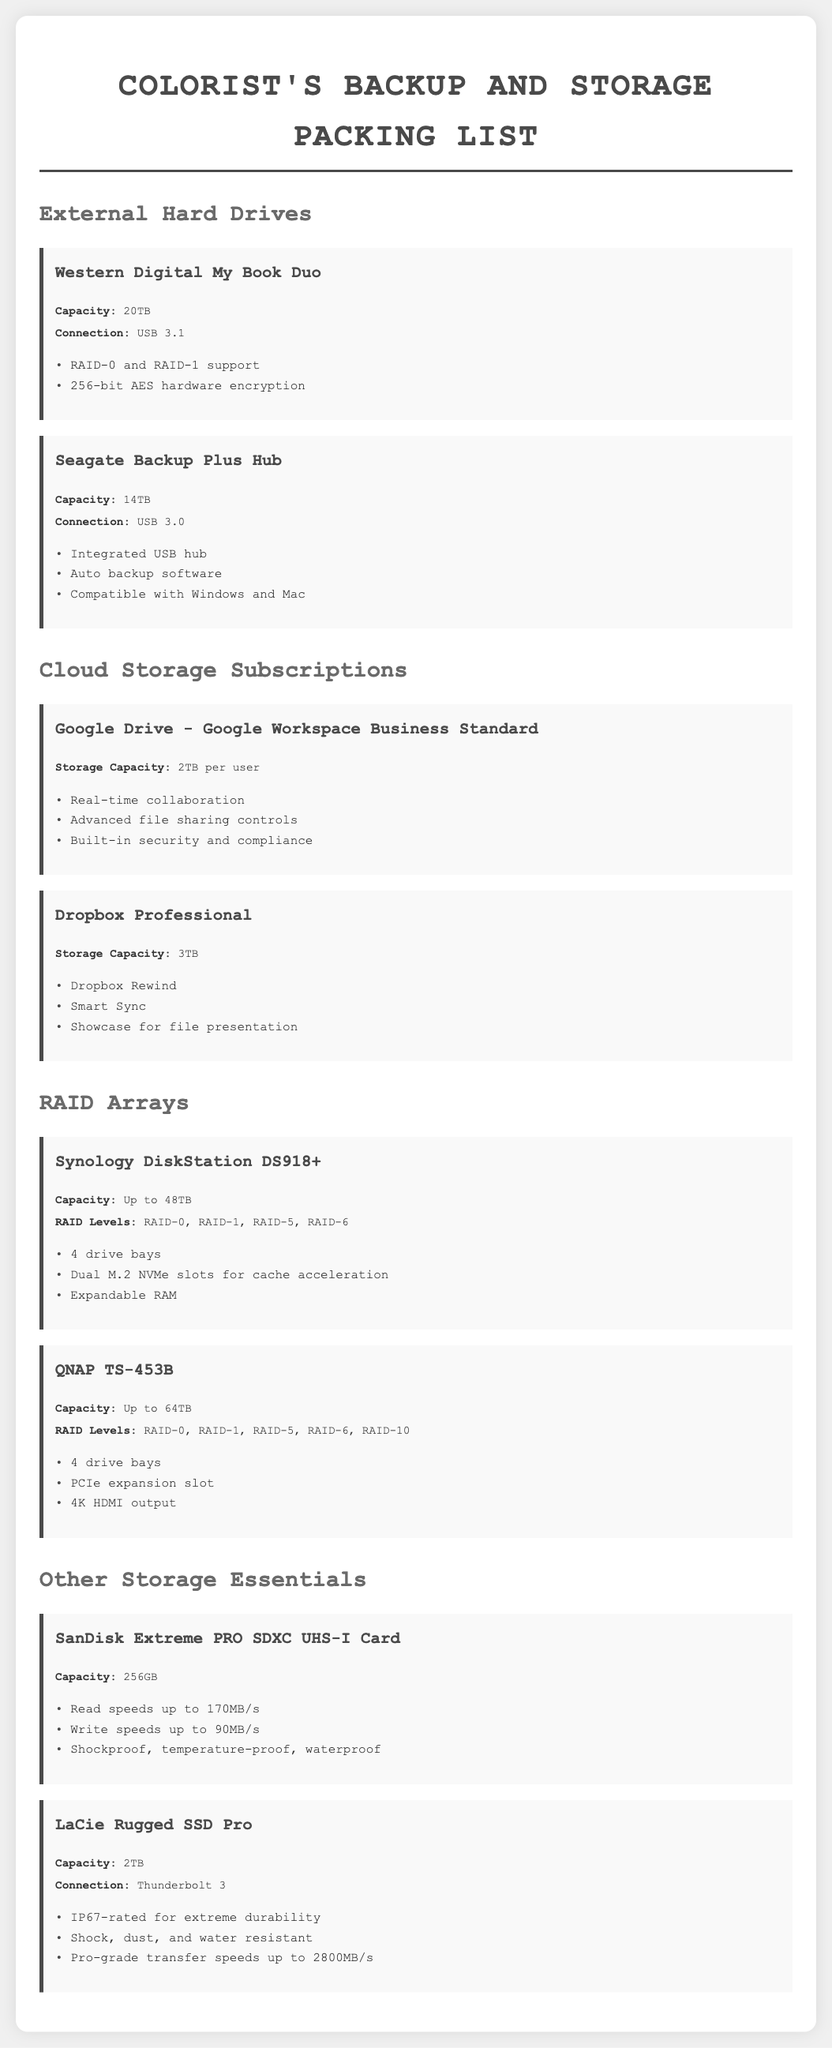What is the capacity of the Western Digital My Book Duo? The capacity is stated directly in the document as 20TB.
Answer: 20TB What type of connection does the Seagate Backup Plus Hub use? The document specifies that it uses a USB 3.0 connection.
Answer: USB 3.0 How much storage does the Dropbox Professional subscription offer? The document lists the storage capacity for Dropbox Professional as 3TB.
Answer: 3TB What RAID levels does the QNAP TS-453B support? The document highlights that it supports multiple RAID levels including RAID-0, RAID-1, RAID-5, RAID-6, and RAID-10.
Answer: RAID-0, RAID-1, RAID-5, RAID-6, RAID-10 What is unique about the SanDisk Extreme PRO SDXC UHS-I Card? The document mentions that it has read speeds up to 170MB/s.
Answer: Read speeds up to 170MB/s Which external hard drive has a RAID-0 and RAID-1 support feature? The document states that the Western Digital My Book Duo supports both RAID-0 and RAID-1.
Answer: Western Digital My Book Duo Which cloud storage solution allows real-time collaboration? The document indicates that Google Drive - Google Workspace Business Standard allows for real-time collaboration.
Answer: Google Drive - Google Workspace Business Standard What is the storage capacity of the Google Drive - Google Workspace Business Standard subscription? The document specifies that it offers 2TB per user.
Answer: 2TB per user How many drive bays does the Synology DiskStation DS918+ have? The document mentions that the Synology DiskStation DS918+ has 4 drive bays.
Answer: 4 drive bays 